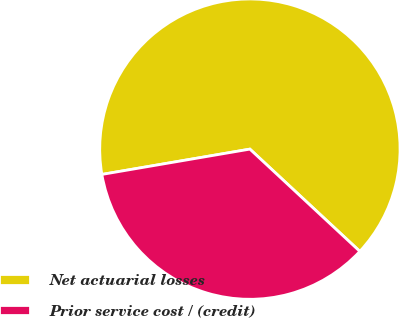Convert chart. <chart><loc_0><loc_0><loc_500><loc_500><pie_chart><fcel>Net actuarial losses<fcel>Prior service cost / (credit)<nl><fcel>64.62%<fcel>35.38%<nl></chart> 